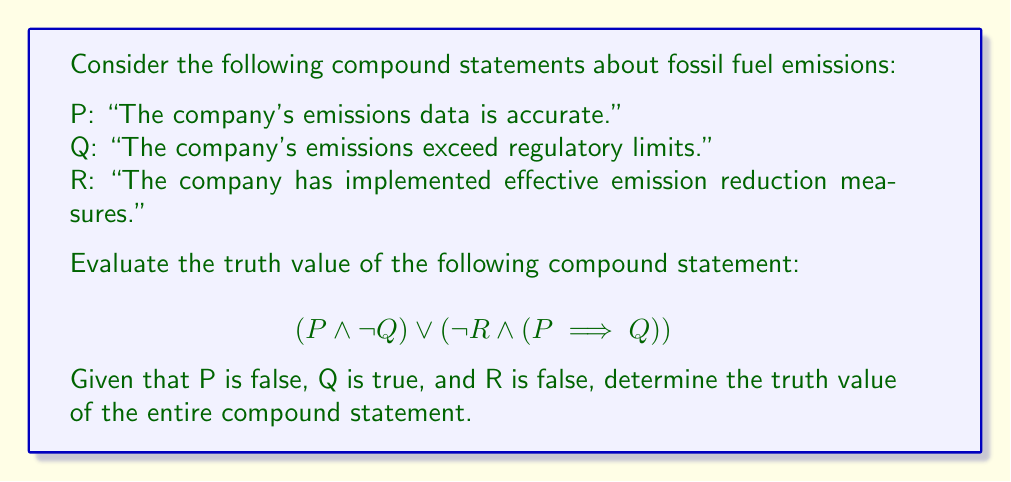Solve this math problem. Let's break this down step-by-step:

1) First, we need to determine the truth values of P, Q, and R:
   P: False
   Q: True
   R: False

2) Now, let's evaluate each part of the compound statement:

   a) $(P \land \neg Q)$:
      P is false, and $\neg Q$ is false (since Q is true).
      False $\land$ False = False

   b) $\neg R$:
      R is false, so $\neg R$ is true.

   c) $(P \implies Q)$:
      When P is false and Q is true, the implication is true.
      (Remember, an implication is only false when the antecedent is true and the consequent is false.)

   d) $(\neg R \land (P \implies Q))$:
      From (b) and (c), we have:
      True $\land$ True = True

3) Now we can evaluate the entire statement:
   $(P \land \neg Q) \lor (\neg R \land (P \implies Q))$
   From steps (a) and (d), this becomes:
   False $\lor$ True = True

Therefore, the entire compound statement evaluates to true.

This result is particularly interesting in the context of our persona. It suggests that even when the company's emissions data is inaccurate (P is false) and emissions do exceed limits (Q is true), the compound statement can still be true if the company has not implemented effective reduction measures (R is false). This highlights how logical analysis can reveal truths about corporate practices even when individual claims might be misleading.
Answer: True 